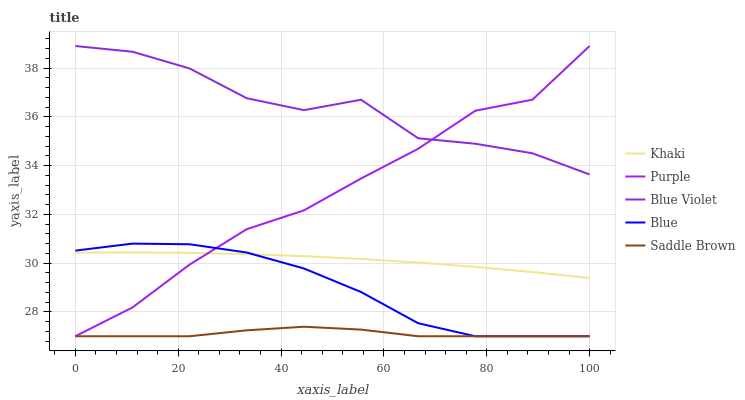Does Saddle Brown have the minimum area under the curve?
Answer yes or no. Yes. Does Blue Violet have the maximum area under the curve?
Answer yes or no. Yes. Does Blue have the minimum area under the curve?
Answer yes or no. No. Does Blue have the maximum area under the curve?
Answer yes or no. No. Is Khaki the smoothest?
Answer yes or no. Yes. Is Blue Violet the roughest?
Answer yes or no. Yes. Is Blue the smoothest?
Answer yes or no. No. Is Blue the roughest?
Answer yes or no. No. Does Khaki have the lowest value?
Answer yes or no. No. Does Purple have the highest value?
Answer yes or no. Yes. Does Blue have the highest value?
Answer yes or no. No. Is Saddle Brown less than Khaki?
Answer yes or no. Yes. Is Blue Violet greater than Khaki?
Answer yes or no. Yes. Does Saddle Brown intersect Blue?
Answer yes or no. Yes. Is Saddle Brown less than Blue?
Answer yes or no. No. Is Saddle Brown greater than Blue?
Answer yes or no. No. Does Saddle Brown intersect Khaki?
Answer yes or no. No. 